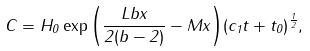Convert formula to latex. <formula><loc_0><loc_0><loc_500><loc_500>C = H _ { 0 } \exp { \left ( \frac { L b x } { 2 ( b - 2 ) } - M x \right ) } ( c _ { 1 } t + t _ { 0 } ) ^ { \frac { 1 } { 2 } } ,</formula> 